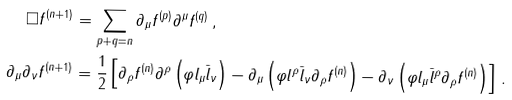<formula> <loc_0><loc_0><loc_500><loc_500>\Box f ^ { ( n + 1 ) } & = \sum _ { p + q = n } \partial _ { \mu } { f ^ { ( p ) } } \partial ^ { \mu } { f ^ { ( q ) } } \, , \\ \partial _ { \mu } \partial _ { \nu } f ^ { ( n + 1 ) } & = \frac { 1 } { 2 } \left [ \partial _ { \rho } f ^ { ( n ) } \partial ^ { \rho } \left ( \varphi l _ { \mu } \bar { l } _ { \nu } \right ) - \partial _ { \mu } \left ( \varphi l ^ { \rho } \bar { l } _ { \nu } \partial _ { \rho } f ^ { ( n ) } \right ) - \partial _ { \nu } \left ( \varphi l _ { \mu } \bar { l } ^ { \rho } \partial _ { \rho } f ^ { ( n ) } \right ) \right ] \, .</formula> 